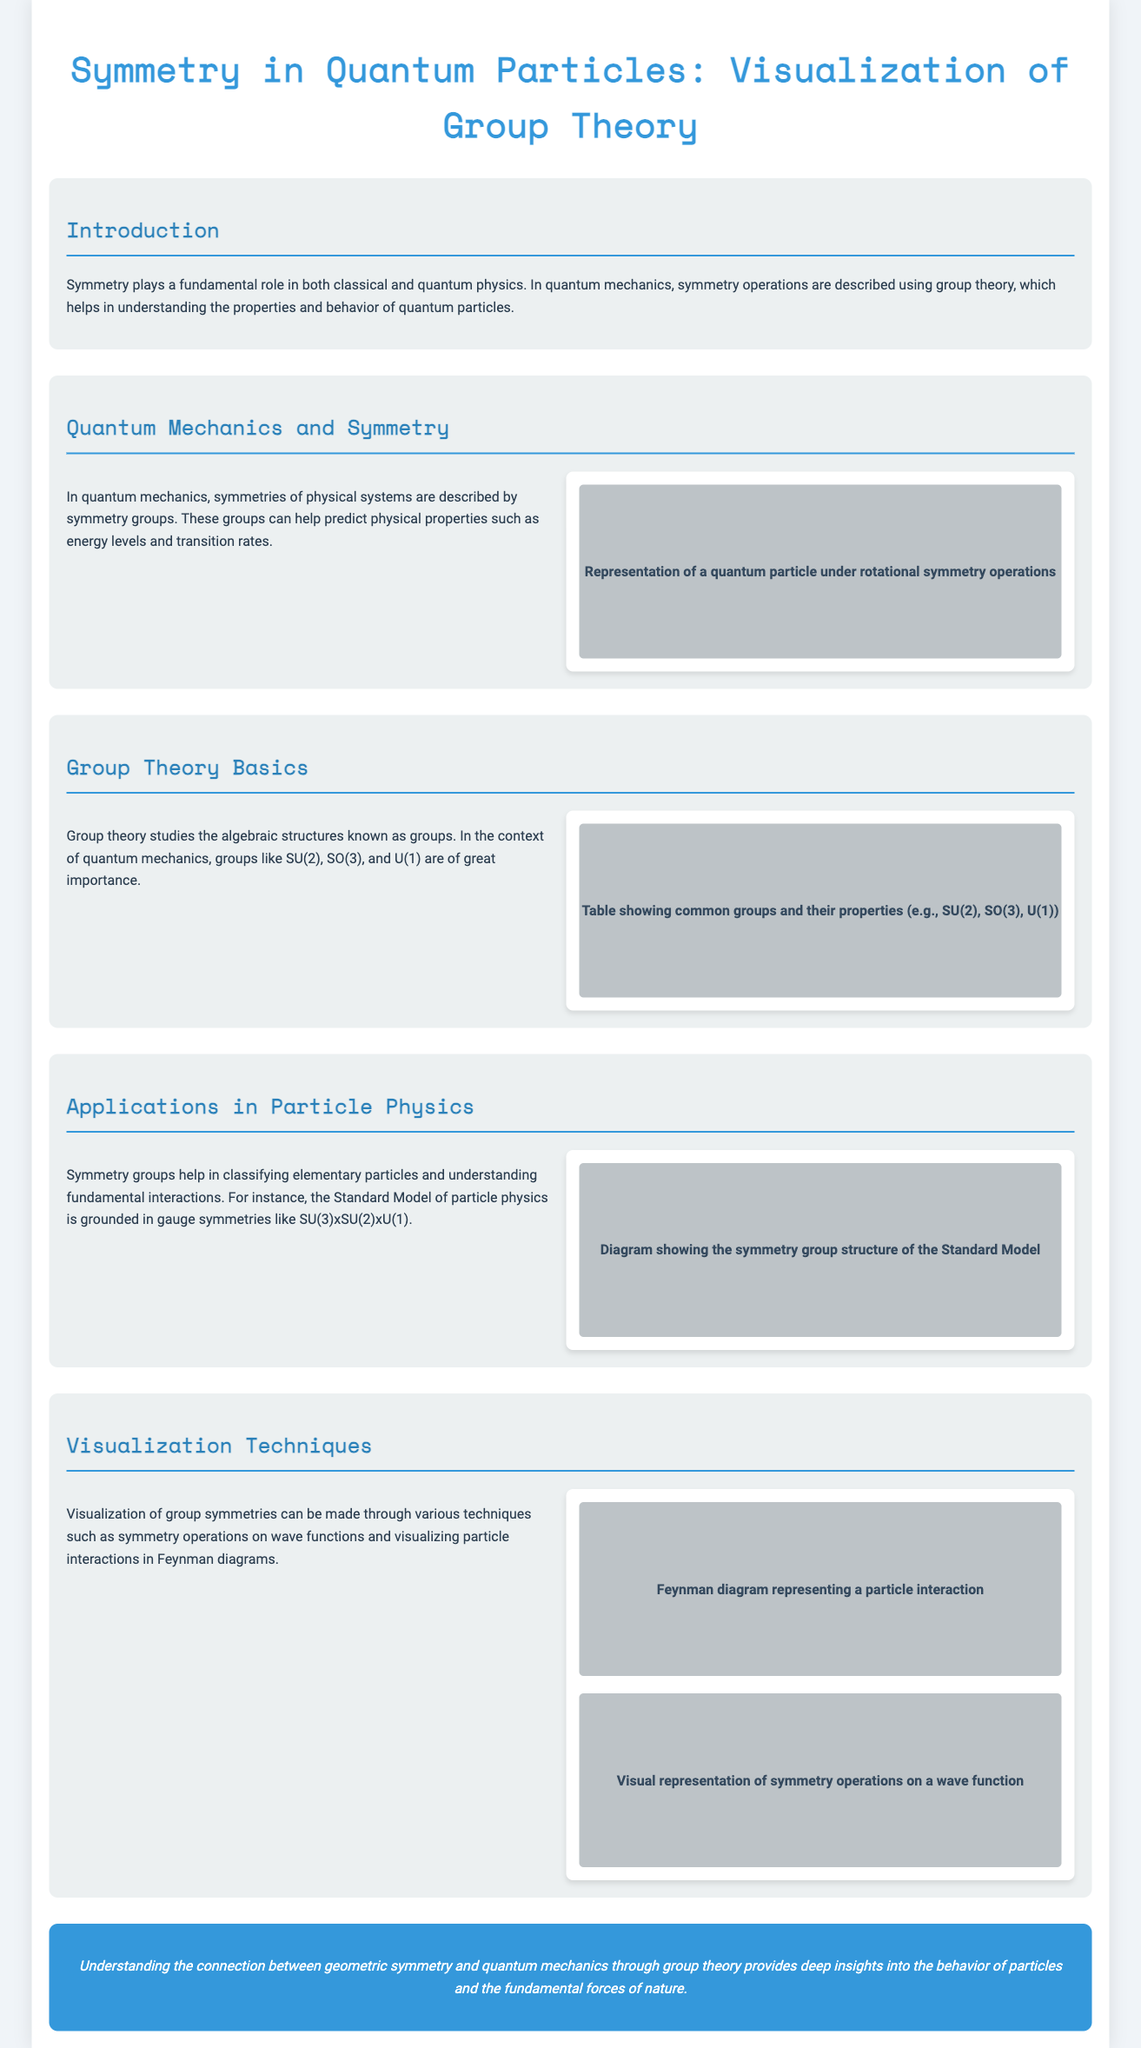What is the main focus of the infographic? The infographic focuses on the relationship between geometric symmetry and quantum mechanics, particularly through group theory.
Answer: geometric symmetry and quantum mechanics Which symmetry groups are mentioned in the document? The document specifically mentions groups like SU(2), SO(3), and U(1).
Answer: SU(2), SO(3), U(1) What is the relationship between symmetry groups and particle classification? Symmetry groups assist in classifying elementary particles and understanding fundamental interactions.
Answer: classifying elementary particles What is a key application of group theory in particle physics? Group theory is foundational for the Standard Model of particle physics, which is based on gauge symmetries like SU(3)xSU(2)xU(1).
Answer: Standard Model What visualization technique is used for particle interactions? Feynman diagrams are a visualization technique used to represent particle interactions.
Answer: Feynman diagrams 